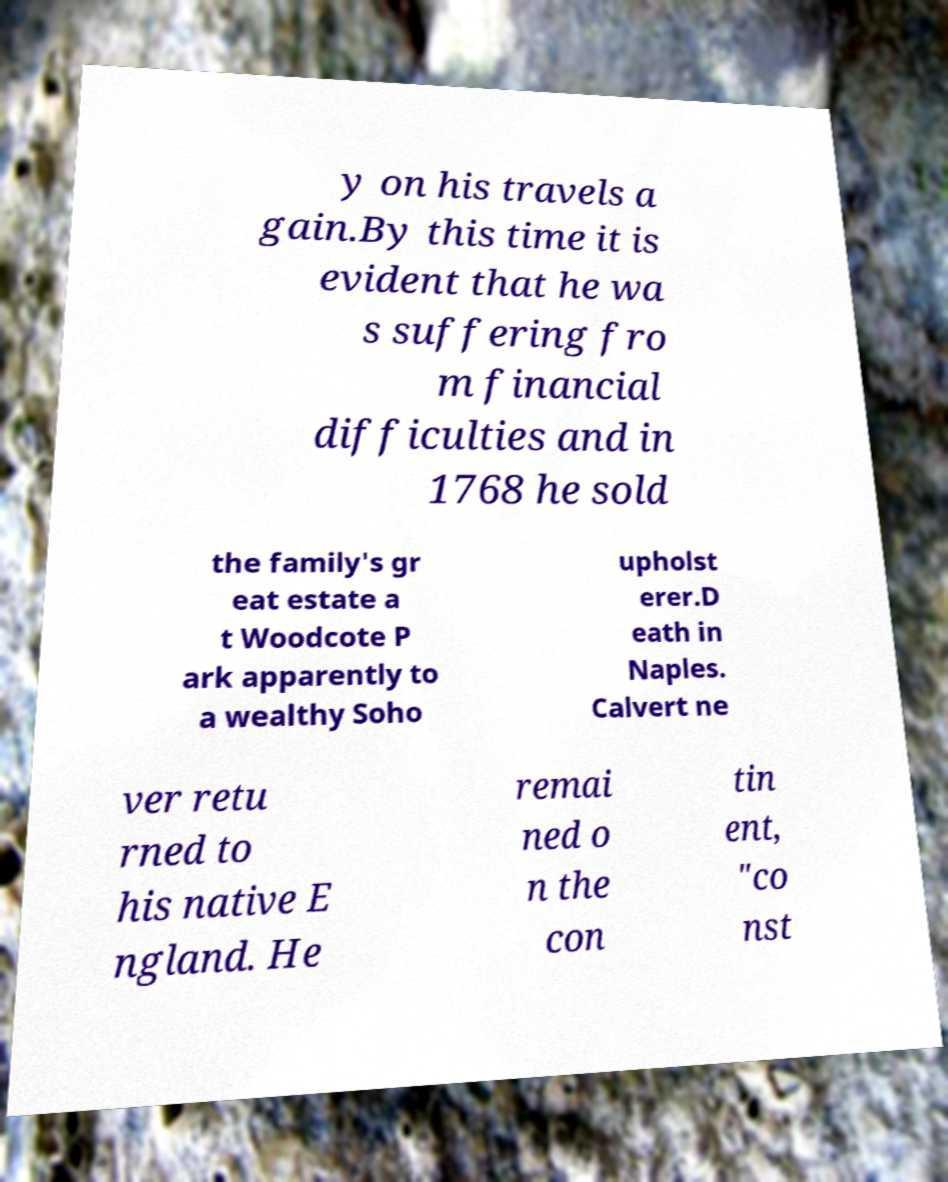I need the written content from this picture converted into text. Can you do that? y on his travels a gain.By this time it is evident that he wa s suffering fro m financial difficulties and in 1768 he sold the family's gr eat estate a t Woodcote P ark apparently to a wealthy Soho upholst erer.D eath in Naples. Calvert ne ver retu rned to his native E ngland. He remai ned o n the con tin ent, "co nst 